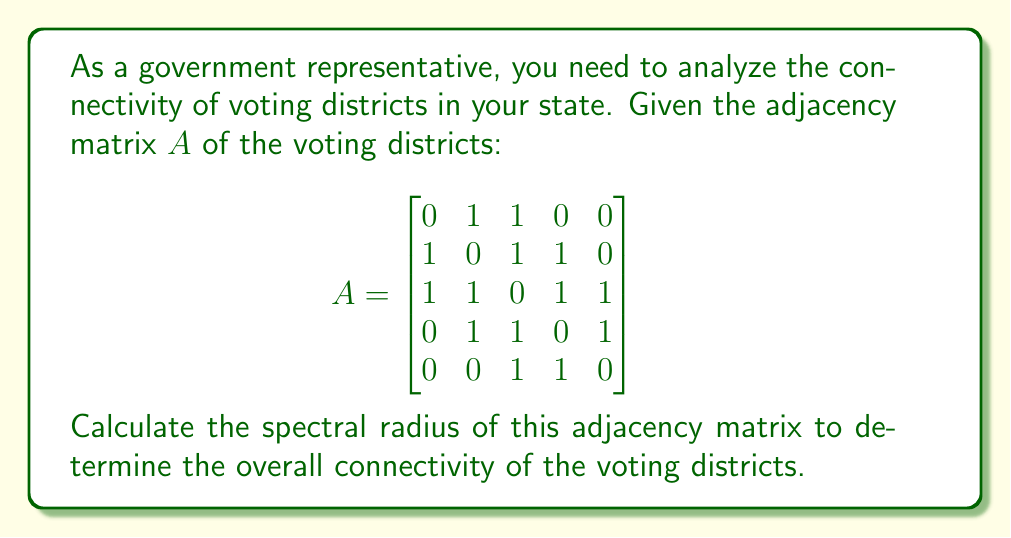What is the answer to this math problem? To calculate the spectral radius of the adjacency matrix, we need to follow these steps:

1) The spectral radius is the largest absolute eigenvalue of the matrix.

2) To find the eigenvalues, we need to solve the characteristic equation:
   $\det(A - \lambda I) = 0$

3) Expanding the determinant:
   $$\begin{vmatrix}
   -\lambda & 1 & 1 & 0 & 0 \\
   1 & -\lambda & 1 & 1 & 0 \\
   1 & 1 & -\lambda & 1 & 1 \\
   0 & 1 & 1 & -\lambda & 1 \\
   0 & 0 & 1 & 1 & -\lambda
   \end{vmatrix} = 0$$

4) This leads to the characteristic polynomial:
   $\lambda^5 - 7\lambda^3 - 4\lambda^2 + 3\lambda + 1 = 0$

5) Solving this equation numerically (as it's a 5th degree polynomial), we get the eigenvalues:
   $\lambda_1 \approx 2.4812$
   $\lambda_2 \approx -1.7321$
   $\lambda_3 \approx 0.7446$
   $\lambda_4 \approx -0.4812$
   $\lambda_5 \approx -0.0125$

6) The spectral radius is the largest absolute value among these eigenvalues.

7) Therefore, the spectral radius is approximately 2.4812.

This value indicates the overall connectivity of the voting districts, with higher values suggesting more interconnected districts.
Answer: 2.4812 